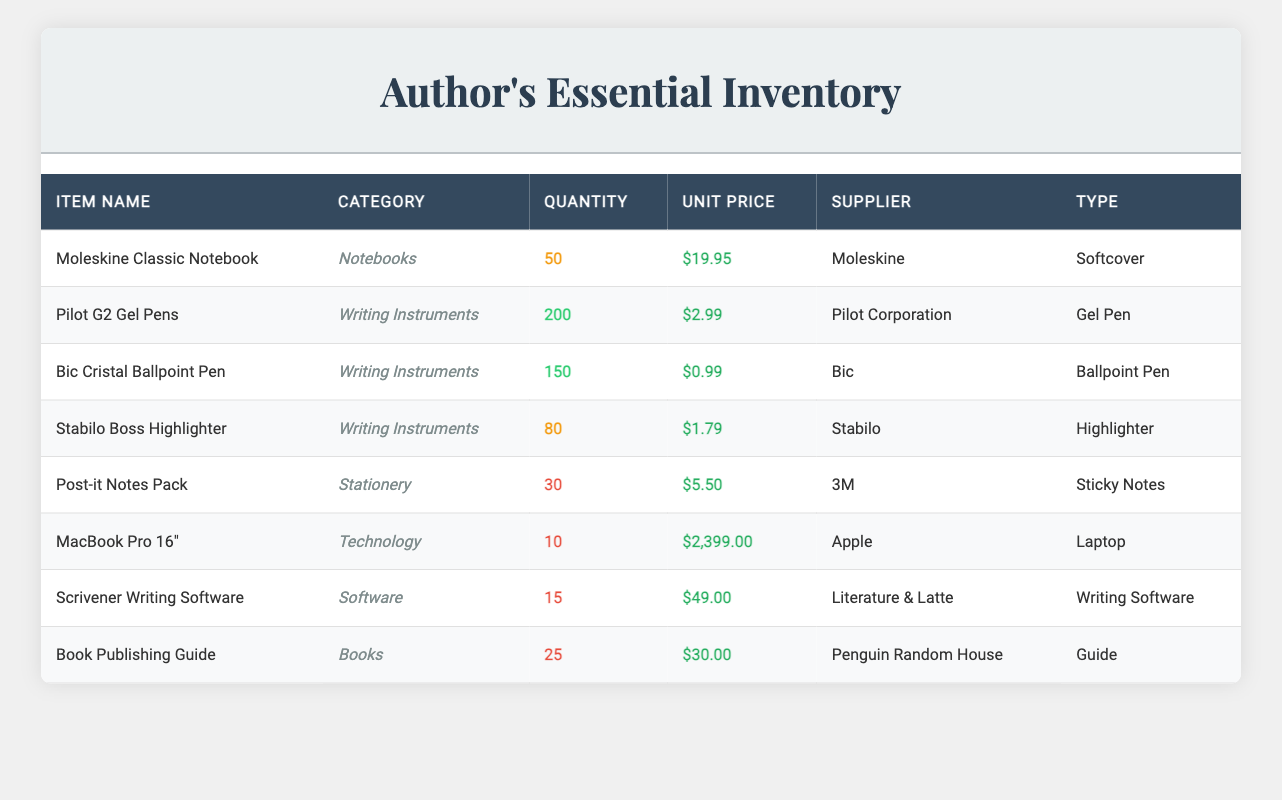What is the total quantity of Pilot G2 Gel Pens in stock? The inventory table lists the quantity of Pilot G2 Gel Pens under the "Quantity" column. The table shows a total of 200 units available.
Answer: 200 Which item has the highest unit price? By comparing the "Unit Price" column for all items, the MacBook Pro 16" has a unit price of $2399.00, which is the highest among all items listed.
Answer: MacBook Pro 16" Is the quantity of Moleskine Classic Notebooks more than that of Stabilo Boss Highlighters? The quantity for Moleskine Classic Notebook is 50, while for Stabilo Boss Highlighter, it is 80. Since 50 is not greater than 80, the answer is no.
Answer: No What is the average unit price of all writing instruments? The writing instruments are Pilot G2 Gel Pens ($2.99), Bic Cristal Ballpoint Pen ($0.99), and Stabilo Boss Highlighter ($1.79). Summing their prices gives $2.99 + $0.99 + $1.79 = $5.77. Dividing by the number of items (3) gives an average of $5.77 / 3 ≈ $1.92.
Answer: Approximately $1.92 How many total items are in stock categorized as "Software"? There is one software item in the inventory table, which is the Scrivener Writing Software, with a quantity of 15. Since that is the only software listed, the total is 15.
Answer: 15 Is there a sufficient quantity of Post-it Notes Pack in stock? The threshold for sufficient stock is generally considered to be above 30 units. The Post-it Notes Pack has 30 units, which meets but does not exceed that amount, thus making it sufficient by typical definitions.
Answer: Yes Calculate the total value of all items in stock. The total value can be calculated by multiplying the unit price by the quantity for each item and then summing these values: (50 * 19.95) + (200 * 2.99) + (150 * 0.99) + (80 * 1.79) + (30 * 5.50) + (10 * 2399.00) + (15 * 49.00) + (25 * 30.00) = $997.50 + $598.00 + $148.50 + $143.20 + $165.00 + $23990.00 + $735.00 + $750.00 = $25983.20.
Answer: $25983.20 Which supplier provides the most number of different items in the inventory? Upon checking, Moleskine provides 1 item, Pilot Corporation provides 1, Bic provides 1, Stabilo provides 1, 3M provides 1, Apple provides 1, Literature & Latte provides 1, and Penguin Random House also provides 1. Each supplier only provides a single item, thus there is no supplier with more than one.
Answer: None How many items categorized under technology are currently in stock? The table shows there is one technology item, the MacBook Pro 16", with a quantity of 10. Thus, there is a total of 10 items in stock in the technology category.
Answer: 10 